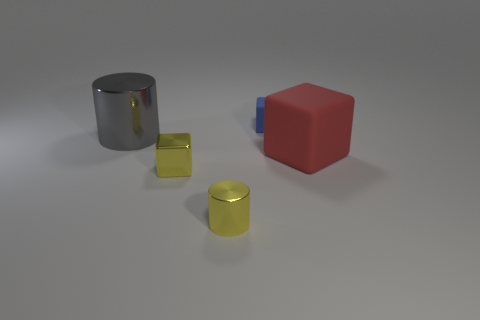Add 4 red cubes. How many objects exist? 9 Subtract 2 cylinders. How many cylinders are left? 0 Subtract all tiny yellow metallic objects. Subtract all yellow shiny blocks. How many objects are left? 2 Add 5 cylinders. How many cylinders are left? 7 Add 3 gray metallic cylinders. How many gray metallic cylinders exist? 4 Subtract all yellow cylinders. How many cylinders are left? 1 Subtract all red cubes. How many cubes are left? 2 Subtract 0 gray blocks. How many objects are left? 5 Subtract all cubes. How many objects are left? 2 Subtract all purple cylinders. Subtract all cyan blocks. How many cylinders are left? 2 